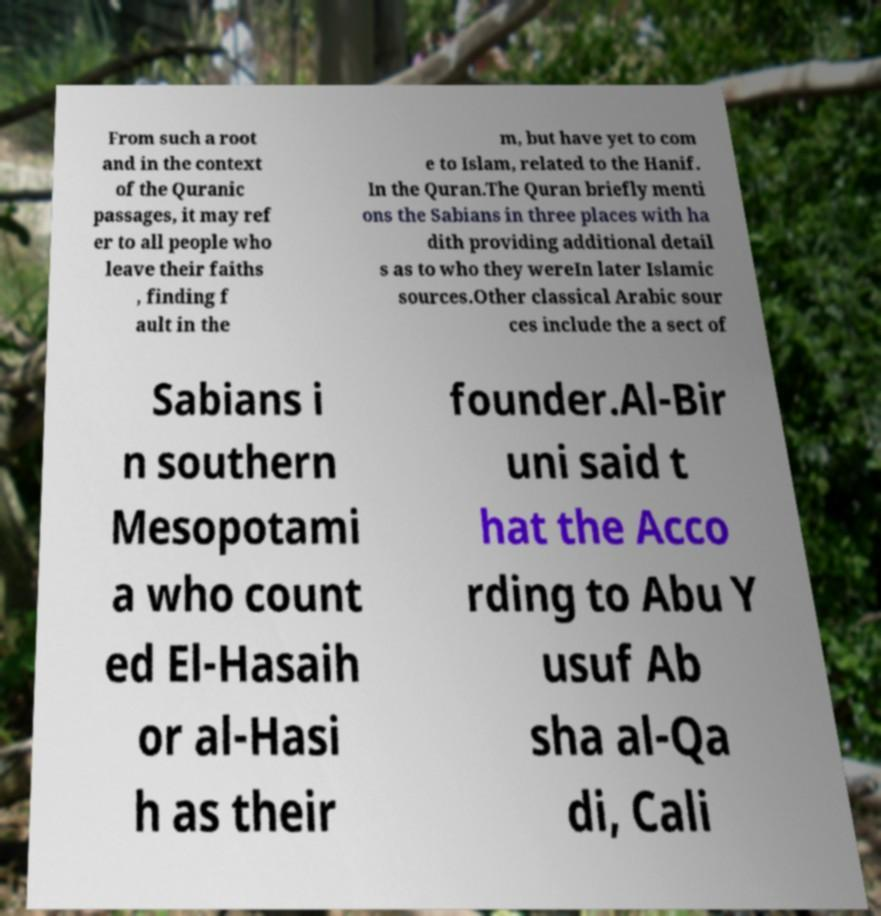Could you assist in decoding the text presented in this image and type it out clearly? From such a root and in the context of the Quranic passages, it may ref er to all people who leave their faiths , finding f ault in the m, but have yet to com e to Islam, related to the Hanif. In the Quran.The Quran briefly menti ons the Sabians in three places with ha dith providing additional detail s as to who they wereIn later Islamic sources.Other classical Arabic sour ces include the a sect of Sabians i n southern Mesopotami a who count ed El-Hasaih or al-Hasi h as their founder.Al-Bir uni said t hat the Acco rding to Abu Y usuf Ab sha al-Qa di, Cali 